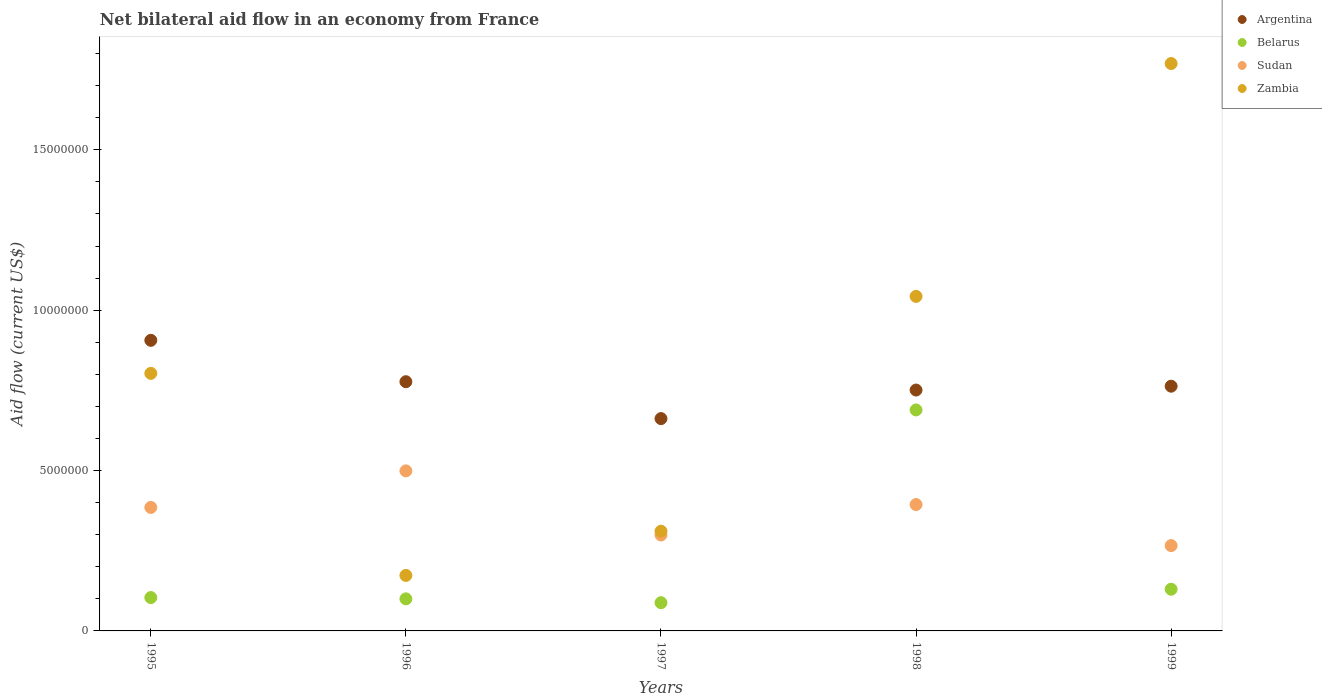What is the net bilateral aid flow in Argentina in 1997?
Keep it short and to the point. 6.62e+06. Across all years, what is the maximum net bilateral aid flow in Argentina?
Your answer should be very brief. 9.06e+06. Across all years, what is the minimum net bilateral aid flow in Belarus?
Give a very brief answer. 8.80e+05. In which year was the net bilateral aid flow in Sudan maximum?
Make the answer very short. 1996. What is the total net bilateral aid flow in Argentina in the graph?
Your answer should be compact. 3.86e+07. What is the difference between the net bilateral aid flow in Belarus in 1995 and that in 1998?
Provide a succinct answer. -5.85e+06. What is the difference between the net bilateral aid flow in Belarus in 1995 and the net bilateral aid flow in Zambia in 1996?
Your answer should be very brief. -6.90e+05. What is the average net bilateral aid flow in Sudan per year?
Offer a terse response. 3.69e+06. In the year 1996, what is the difference between the net bilateral aid flow in Zambia and net bilateral aid flow in Argentina?
Your answer should be compact. -6.04e+06. What is the ratio of the net bilateral aid flow in Sudan in 1997 to that in 1999?
Offer a terse response. 1.12. What is the difference between the highest and the second highest net bilateral aid flow in Sudan?
Provide a succinct answer. 1.05e+06. What is the difference between the highest and the lowest net bilateral aid flow in Belarus?
Your answer should be compact. 6.01e+06. Is the sum of the net bilateral aid flow in Zambia in 1995 and 1999 greater than the maximum net bilateral aid flow in Argentina across all years?
Provide a short and direct response. Yes. Does the net bilateral aid flow in Zambia monotonically increase over the years?
Your response must be concise. No. Is the net bilateral aid flow in Sudan strictly greater than the net bilateral aid flow in Argentina over the years?
Your answer should be very brief. No. Is the net bilateral aid flow in Belarus strictly less than the net bilateral aid flow in Sudan over the years?
Make the answer very short. No. How many dotlines are there?
Your answer should be compact. 4. Are the values on the major ticks of Y-axis written in scientific E-notation?
Provide a succinct answer. No. Does the graph contain any zero values?
Make the answer very short. No. Where does the legend appear in the graph?
Offer a very short reply. Top right. How are the legend labels stacked?
Offer a very short reply. Vertical. What is the title of the graph?
Provide a short and direct response. Net bilateral aid flow in an economy from France. Does "Turkmenistan" appear as one of the legend labels in the graph?
Offer a very short reply. No. What is the Aid flow (current US$) of Argentina in 1995?
Keep it short and to the point. 9.06e+06. What is the Aid flow (current US$) of Belarus in 1995?
Offer a very short reply. 1.04e+06. What is the Aid flow (current US$) in Sudan in 1995?
Your answer should be compact. 3.85e+06. What is the Aid flow (current US$) in Zambia in 1995?
Provide a succinct answer. 8.03e+06. What is the Aid flow (current US$) in Argentina in 1996?
Give a very brief answer. 7.77e+06. What is the Aid flow (current US$) of Sudan in 1996?
Offer a very short reply. 4.99e+06. What is the Aid flow (current US$) of Zambia in 1996?
Ensure brevity in your answer.  1.73e+06. What is the Aid flow (current US$) in Argentina in 1997?
Give a very brief answer. 6.62e+06. What is the Aid flow (current US$) in Belarus in 1997?
Provide a short and direct response. 8.80e+05. What is the Aid flow (current US$) of Sudan in 1997?
Your response must be concise. 2.99e+06. What is the Aid flow (current US$) of Zambia in 1997?
Keep it short and to the point. 3.11e+06. What is the Aid flow (current US$) of Argentina in 1998?
Ensure brevity in your answer.  7.51e+06. What is the Aid flow (current US$) of Belarus in 1998?
Provide a succinct answer. 6.89e+06. What is the Aid flow (current US$) of Sudan in 1998?
Give a very brief answer. 3.94e+06. What is the Aid flow (current US$) of Zambia in 1998?
Your response must be concise. 1.04e+07. What is the Aid flow (current US$) of Argentina in 1999?
Your response must be concise. 7.63e+06. What is the Aid flow (current US$) of Belarus in 1999?
Make the answer very short. 1.30e+06. What is the Aid flow (current US$) in Sudan in 1999?
Give a very brief answer. 2.66e+06. What is the Aid flow (current US$) in Zambia in 1999?
Give a very brief answer. 1.77e+07. Across all years, what is the maximum Aid flow (current US$) of Argentina?
Your answer should be compact. 9.06e+06. Across all years, what is the maximum Aid flow (current US$) in Belarus?
Provide a succinct answer. 6.89e+06. Across all years, what is the maximum Aid flow (current US$) of Sudan?
Give a very brief answer. 4.99e+06. Across all years, what is the maximum Aid flow (current US$) in Zambia?
Make the answer very short. 1.77e+07. Across all years, what is the minimum Aid flow (current US$) of Argentina?
Offer a terse response. 6.62e+06. Across all years, what is the minimum Aid flow (current US$) in Belarus?
Your response must be concise. 8.80e+05. Across all years, what is the minimum Aid flow (current US$) of Sudan?
Provide a short and direct response. 2.66e+06. Across all years, what is the minimum Aid flow (current US$) of Zambia?
Make the answer very short. 1.73e+06. What is the total Aid flow (current US$) in Argentina in the graph?
Ensure brevity in your answer.  3.86e+07. What is the total Aid flow (current US$) of Belarus in the graph?
Keep it short and to the point. 1.11e+07. What is the total Aid flow (current US$) of Sudan in the graph?
Give a very brief answer. 1.84e+07. What is the total Aid flow (current US$) in Zambia in the graph?
Keep it short and to the point. 4.10e+07. What is the difference between the Aid flow (current US$) of Argentina in 1995 and that in 1996?
Your answer should be compact. 1.29e+06. What is the difference between the Aid flow (current US$) of Sudan in 1995 and that in 1996?
Provide a short and direct response. -1.14e+06. What is the difference between the Aid flow (current US$) in Zambia in 1995 and that in 1996?
Your answer should be compact. 6.30e+06. What is the difference between the Aid flow (current US$) of Argentina in 1995 and that in 1997?
Your answer should be compact. 2.44e+06. What is the difference between the Aid flow (current US$) in Belarus in 1995 and that in 1997?
Ensure brevity in your answer.  1.60e+05. What is the difference between the Aid flow (current US$) in Sudan in 1995 and that in 1997?
Provide a succinct answer. 8.60e+05. What is the difference between the Aid flow (current US$) of Zambia in 1995 and that in 1997?
Your response must be concise. 4.92e+06. What is the difference between the Aid flow (current US$) of Argentina in 1995 and that in 1998?
Provide a succinct answer. 1.55e+06. What is the difference between the Aid flow (current US$) in Belarus in 1995 and that in 1998?
Keep it short and to the point. -5.85e+06. What is the difference between the Aid flow (current US$) in Sudan in 1995 and that in 1998?
Make the answer very short. -9.00e+04. What is the difference between the Aid flow (current US$) of Zambia in 1995 and that in 1998?
Ensure brevity in your answer.  -2.40e+06. What is the difference between the Aid flow (current US$) in Argentina in 1995 and that in 1999?
Your answer should be compact. 1.43e+06. What is the difference between the Aid flow (current US$) in Belarus in 1995 and that in 1999?
Make the answer very short. -2.60e+05. What is the difference between the Aid flow (current US$) of Sudan in 1995 and that in 1999?
Make the answer very short. 1.19e+06. What is the difference between the Aid flow (current US$) in Zambia in 1995 and that in 1999?
Your answer should be compact. -9.66e+06. What is the difference between the Aid flow (current US$) of Argentina in 1996 and that in 1997?
Keep it short and to the point. 1.15e+06. What is the difference between the Aid flow (current US$) of Belarus in 1996 and that in 1997?
Ensure brevity in your answer.  1.20e+05. What is the difference between the Aid flow (current US$) in Sudan in 1996 and that in 1997?
Ensure brevity in your answer.  2.00e+06. What is the difference between the Aid flow (current US$) of Zambia in 1996 and that in 1997?
Make the answer very short. -1.38e+06. What is the difference between the Aid flow (current US$) in Argentina in 1996 and that in 1998?
Keep it short and to the point. 2.60e+05. What is the difference between the Aid flow (current US$) of Belarus in 1996 and that in 1998?
Provide a succinct answer. -5.89e+06. What is the difference between the Aid flow (current US$) in Sudan in 1996 and that in 1998?
Make the answer very short. 1.05e+06. What is the difference between the Aid flow (current US$) of Zambia in 1996 and that in 1998?
Make the answer very short. -8.70e+06. What is the difference between the Aid flow (current US$) of Belarus in 1996 and that in 1999?
Provide a short and direct response. -3.00e+05. What is the difference between the Aid flow (current US$) of Sudan in 1996 and that in 1999?
Your answer should be very brief. 2.33e+06. What is the difference between the Aid flow (current US$) of Zambia in 1996 and that in 1999?
Make the answer very short. -1.60e+07. What is the difference between the Aid flow (current US$) of Argentina in 1997 and that in 1998?
Offer a terse response. -8.90e+05. What is the difference between the Aid flow (current US$) of Belarus in 1997 and that in 1998?
Provide a short and direct response. -6.01e+06. What is the difference between the Aid flow (current US$) of Sudan in 1997 and that in 1998?
Your answer should be compact. -9.50e+05. What is the difference between the Aid flow (current US$) in Zambia in 1997 and that in 1998?
Your response must be concise. -7.32e+06. What is the difference between the Aid flow (current US$) of Argentina in 1997 and that in 1999?
Keep it short and to the point. -1.01e+06. What is the difference between the Aid flow (current US$) of Belarus in 1997 and that in 1999?
Make the answer very short. -4.20e+05. What is the difference between the Aid flow (current US$) of Zambia in 1997 and that in 1999?
Keep it short and to the point. -1.46e+07. What is the difference between the Aid flow (current US$) of Belarus in 1998 and that in 1999?
Make the answer very short. 5.59e+06. What is the difference between the Aid flow (current US$) of Sudan in 1998 and that in 1999?
Ensure brevity in your answer.  1.28e+06. What is the difference between the Aid flow (current US$) of Zambia in 1998 and that in 1999?
Provide a short and direct response. -7.26e+06. What is the difference between the Aid flow (current US$) in Argentina in 1995 and the Aid flow (current US$) in Belarus in 1996?
Offer a terse response. 8.06e+06. What is the difference between the Aid flow (current US$) of Argentina in 1995 and the Aid flow (current US$) of Sudan in 1996?
Your response must be concise. 4.07e+06. What is the difference between the Aid flow (current US$) of Argentina in 1995 and the Aid flow (current US$) of Zambia in 1996?
Your response must be concise. 7.33e+06. What is the difference between the Aid flow (current US$) in Belarus in 1995 and the Aid flow (current US$) in Sudan in 1996?
Give a very brief answer. -3.95e+06. What is the difference between the Aid flow (current US$) in Belarus in 1995 and the Aid flow (current US$) in Zambia in 1996?
Your response must be concise. -6.90e+05. What is the difference between the Aid flow (current US$) of Sudan in 1995 and the Aid flow (current US$) of Zambia in 1996?
Offer a very short reply. 2.12e+06. What is the difference between the Aid flow (current US$) of Argentina in 1995 and the Aid flow (current US$) of Belarus in 1997?
Your answer should be very brief. 8.18e+06. What is the difference between the Aid flow (current US$) of Argentina in 1995 and the Aid flow (current US$) of Sudan in 1997?
Your answer should be compact. 6.07e+06. What is the difference between the Aid flow (current US$) in Argentina in 1995 and the Aid flow (current US$) in Zambia in 1997?
Give a very brief answer. 5.95e+06. What is the difference between the Aid flow (current US$) of Belarus in 1995 and the Aid flow (current US$) of Sudan in 1997?
Your response must be concise. -1.95e+06. What is the difference between the Aid flow (current US$) of Belarus in 1995 and the Aid flow (current US$) of Zambia in 1997?
Ensure brevity in your answer.  -2.07e+06. What is the difference between the Aid flow (current US$) in Sudan in 1995 and the Aid flow (current US$) in Zambia in 1997?
Offer a terse response. 7.40e+05. What is the difference between the Aid flow (current US$) in Argentina in 1995 and the Aid flow (current US$) in Belarus in 1998?
Give a very brief answer. 2.17e+06. What is the difference between the Aid flow (current US$) of Argentina in 1995 and the Aid flow (current US$) of Sudan in 1998?
Your answer should be very brief. 5.12e+06. What is the difference between the Aid flow (current US$) of Argentina in 1995 and the Aid flow (current US$) of Zambia in 1998?
Provide a succinct answer. -1.37e+06. What is the difference between the Aid flow (current US$) in Belarus in 1995 and the Aid flow (current US$) in Sudan in 1998?
Your answer should be very brief. -2.90e+06. What is the difference between the Aid flow (current US$) of Belarus in 1995 and the Aid flow (current US$) of Zambia in 1998?
Give a very brief answer. -9.39e+06. What is the difference between the Aid flow (current US$) in Sudan in 1995 and the Aid flow (current US$) in Zambia in 1998?
Give a very brief answer. -6.58e+06. What is the difference between the Aid flow (current US$) in Argentina in 1995 and the Aid flow (current US$) in Belarus in 1999?
Offer a very short reply. 7.76e+06. What is the difference between the Aid flow (current US$) in Argentina in 1995 and the Aid flow (current US$) in Sudan in 1999?
Keep it short and to the point. 6.40e+06. What is the difference between the Aid flow (current US$) of Argentina in 1995 and the Aid flow (current US$) of Zambia in 1999?
Give a very brief answer. -8.63e+06. What is the difference between the Aid flow (current US$) in Belarus in 1995 and the Aid flow (current US$) in Sudan in 1999?
Provide a succinct answer. -1.62e+06. What is the difference between the Aid flow (current US$) in Belarus in 1995 and the Aid flow (current US$) in Zambia in 1999?
Provide a succinct answer. -1.66e+07. What is the difference between the Aid flow (current US$) in Sudan in 1995 and the Aid flow (current US$) in Zambia in 1999?
Provide a succinct answer. -1.38e+07. What is the difference between the Aid flow (current US$) in Argentina in 1996 and the Aid flow (current US$) in Belarus in 1997?
Make the answer very short. 6.89e+06. What is the difference between the Aid flow (current US$) in Argentina in 1996 and the Aid flow (current US$) in Sudan in 1997?
Your answer should be very brief. 4.78e+06. What is the difference between the Aid flow (current US$) of Argentina in 1996 and the Aid flow (current US$) of Zambia in 1997?
Your answer should be very brief. 4.66e+06. What is the difference between the Aid flow (current US$) in Belarus in 1996 and the Aid flow (current US$) in Sudan in 1997?
Keep it short and to the point. -1.99e+06. What is the difference between the Aid flow (current US$) in Belarus in 1996 and the Aid flow (current US$) in Zambia in 1997?
Keep it short and to the point. -2.11e+06. What is the difference between the Aid flow (current US$) in Sudan in 1996 and the Aid flow (current US$) in Zambia in 1997?
Keep it short and to the point. 1.88e+06. What is the difference between the Aid flow (current US$) in Argentina in 1996 and the Aid flow (current US$) in Belarus in 1998?
Your answer should be very brief. 8.80e+05. What is the difference between the Aid flow (current US$) of Argentina in 1996 and the Aid flow (current US$) of Sudan in 1998?
Give a very brief answer. 3.83e+06. What is the difference between the Aid flow (current US$) of Argentina in 1996 and the Aid flow (current US$) of Zambia in 1998?
Keep it short and to the point. -2.66e+06. What is the difference between the Aid flow (current US$) in Belarus in 1996 and the Aid flow (current US$) in Sudan in 1998?
Provide a short and direct response. -2.94e+06. What is the difference between the Aid flow (current US$) in Belarus in 1996 and the Aid flow (current US$) in Zambia in 1998?
Your answer should be very brief. -9.43e+06. What is the difference between the Aid flow (current US$) of Sudan in 1996 and the Aid flow (current US$) of Zambia in 1998?
Provide a succinct answer. -5.44e+06. What is the difference between the Aid flow (current US$) in Argentina in 1996 and the Aid flow (current US$) in Belarus in 1999?
Offer a very short reply. 6.47e+06. What is the difference between the Aid flow (current US$) of Argentina in 1996 and the Aid flow (current US$) of Sudan in 1999?
Give a very brief answer. 5.11e+06. What is the difference between the Aid flow (current US$) in Argentina in 1996 and the Aid flow (current US$) in Zambia in 1999?
Offer a terse response. -9.92e+06. What is the difference between the Aid flow (current US$) in Belarus in 1996 and the Aid flow (current US$) in Sudan in 1999?
Ensure brevity in your answer.  -1.66e+06. What is the difference between the Aid flow (current US$) in Belarus in 1996 and the Aid flow (current US$) in Zambia in 1999?
Make the answer very short. -1.67e+07. What is the difference between the Aid flow (current US$) in Sudan in 1996 and the Aid flow (current US$) in Zambia in 1999?
Your answer should be compact. -1.27e+07. What is the difference between the Aid flow (current US$) in Argentina in 1997 and the Aid flow (current US$) in Sudan in 1998?
Your response must be concise. 2.68e+06. What is the difference between the Aid flow (current US$) in Argentina in 1997 and the Aid flow (current US$) in Zambia in 1998?
Your answer should be very brief. -3.81e+06. What is the difference between the Aid flow (current US$) of Belarus in 1997 and the Aid flow (current US$) of Sudan in 1998?
Provide a short and direct response. -3.06e+06. What is the difference between the Aid flow (current US$) of Belarus in 1997 and the Aid flow (current US$) of Zambia in 1998?
Provide a short and direct response. -9.55e+06. What is the difference between the Aid flow (current US$) in Sudan in 1997 and the Aid flow (current US$) in Zambia in 1998?
Make the answer very short. -7.44e+06. What is the difference between the Aid flow (current US$) in Argentina in 1997 and the Aid flow (current US$) in Belarus in 1999?
Your answer should be compact. 5.32e+06. What is the difference between the Aid flow (current US$) of Argentina in 1997 and the Aid flow (current US$) of Sudan in 1999?
Provide a short and direct response. 3.96e+06. What is the difference between the Aid flow (current US$) in Argentina in 1997 and the Aid flow (current US$) in Zambia in 1999?
Provide a succinct answer. -1.11e+07. What is the difference between the Aid flow (current US$) of Belarus in 1997 and the Aid flow (current US$) of Sudan in 1999?
Make the answer very short. -1.78e+06. What is the difference between the Aid flow (current US$) in Belarus in 1997 and the Aid flow (current US$) in Zambia in 1999?
Provide a succinct answer. -1.68e+07. What is the difference between the Aid flow (current US$) of Sudan in 1997 and the Aid flow (current US$) of Zambia in 1999?
Keep it short and to the point. -1.47e+07. What is the difference between the Aid flow (current US$) in Argentina in 1998 and the Aid flow (current US$) in Belarus in 1999?
Provide a short and direct response. 6.21e+06. What is the difference between the Aid flow (current US$) in Argentina in 1998 and the Aid flow (current US$) in Sudan in 1999?
Offer a terse response. 4.85e+06. What is the difference between the Aid flow (current US$) in Argentina in 1998 and the Aid flow (current US$) in Zambia in 1999?
Your answer should be compact. -1.02e+07. What is the difference between the Aid flow (current US$) in Belarus in 1998 and the Aid flow (current US$) in Sudan in 1999?
Give a very brief answer. 4.23e+06. What is the difference between the Aid flow (current US$) in Belarus in 1998 and the Aid flow (current US$) in Zambia in 1999?
Your answer should be very brief. -1.08e+07. What is the difference between the Aid flow (current US$) in Sudan in 1998 and the Aid flow (current US$) in Zambia in 1999?
Offer a terse response. -1.38e+07. What is the average Aid flow (current US$) in Argentina per year?
Give a very brief answer. 7.72e+06. What is the average Aid flow (current US$) in Belarus per year?
Provide a short and direct response. 2.22e+06. What is the average Aid flow (current US$) in Sudan per year?
Your answer should be very brief. 3.69e+06. What is the average Aid flow (current US$) in Zambia per year?
Your answer should be compact. 8.20e+06. In the year 1995, what is the difference between the Aid flow (current US$) in Argentina and Aid flow (current US$) in Belarus?
Offer a very short reply. 8.02e+06. In the year 1995, what is the difference between the Aid flow (current US$) of Argentina and Aid flow (current US$) of Sudan?
Make the answer very short. 5.21e+06. In the year 1995, what is the difference between the Aid flow (current US$) of Argentina and Aid flow (current US$) of Zambia?
Your answer should be compact. 1.03e+06. In the year 1995, what is the difference between the Aid flow (current US$) in Belarus and Aid flow (current US$) in Sudan?
Ensure brevity in your answer.  -2.81e+06. In the year 1995, what is the difference between the Aid flow (current US$) of Belarus and Aid flow (current US$) of Zambia?
Give a very brief answer. -6.99e+06. In the year 1995, what is the difference between the Aid flow (current US$) of Sudan and Aid flow (current US$) of Zambia?
Give a very brief answer. -4.18e+06. In the year 1996, what is the difference between the Aid flow (current US$) in Argentina and Aid flow (current US$) in Belarus?
Give a very brief answer. 6.77e+06. In the year 1996, what is the difference between the Aid flow (current US$) in Argentina and Aid flow (current US$) in Sudan?
Keep it short and to the point. 2.78e+06. In the year 1996, what is the difference between the Aid flow (current US$) of Argentina and Aid flow (current US$) of Zambia?
Offer a very short reply. 6.04e+06. In the year 1996, what is the difference between the Aid flow (current US$) of Belarus and Aid flow (current US$) of Sudan?
Your response must be concise. -3.99e+06. In the year 1996, what is the difference between the Aid flow (current US$) in Belarus and Aid flow (current US$) in Zambia?
Provide a succinct answer. -7.30e+05. In the year 1996, what is the difference between the Aid flow (current US$) of Sudan and Aid flow (current US$) of Zambia?
Make the answer very short. 3.26e+06. In the year 1997, what is the difference between the Aid flow (current US$) in Argentina and Aid flow (current US$) in Belarus?
Provide a succinct answer. 5.74e+06. In the year 1997, what is the difference between the Aid flow (current US$) of Argentina and Aid flow (current US$) of Sudan?
Offer a very short reply. 3.63e+06. In the year 1997, what is the difference between the Aid flow (current US$) in Argentina and Aid flow (current US$) in Zambia?
Your answer should be very brief. 3.51e+06. In the year 1997, what is the difference between the Aid flow (current US$) in Belarus and Aid flow (current US$) in Sudan?
Provide a short and direct response. -2.11e+06. In the year 1997, what is the difference between the Aid flow (current US$) in Belarus and Aid flow (current US$) in Zambia?
Make the answer very short. -2.23e+06. In the year 1997, what is the difference between the Aid flow (current US$) in Sudan and Aid flow (current US$) in Zambia?
Offer a very short reply. -1.20e+05. In the year 1998, what is the difference between the Aid flow (current US$) in Argentina and Aid flow (current US$) in Belarus?
Make the answer very short. 6.20e+05. In the year 1998, what is the difference between the Aid flow (current US$) in Argentina and Aid flow (current US$) in Sudan?
Your answer should be very brief. 3.57e+06. In the year 1998, what is the difference between the Aid flow (current US$) in Argentina and Aid flow (current US$) in Zambia?
Provide a succinct answer. -2.92e+06. In the year 1998, what is the difference between the Aid flow (current US$) in Belarus and Aid flow (current US$) in Sudan?
Your answer should be compact. 2.95e+06. In the year 1998, what is the difference between the Aid flow (current US$) in Belarus and Aid flow (current US$) in Zambia?
Give a very brief answer. -3.54e+06. In the year 1998, what is the difference between the Aid flow (current US$) of Sudan and Aid flow (current US$) of Zambia?
Provide a succinct answer. -6.49e+06. In the year 1999, what is the difference between the Aid flow (current US$) of Argentina and Aid flow (current US$) of Belarus?
Provide a short and direct response. 6.33e+06. In the year 1999, what is the difference between the Aid flow (current US$) in Argentina and Aid flow (current US$) in Sudan?
Your answer should be very brief. 4.97e+06. In the year 1999, what is the difference between the Aid flow (current US$) in Argentina and Aid flow (current US$) in Zambia?
Offer a very short reply. -1.01e+07. In the year 1999, what is the difference between the Aid flow (current US$) in Belarus and Aid flow (current US$) in Sudan?
Your answer should be very brief. -1.36e+06. In the year 1999, what is the difference between the Aid flow (current US$) of Belarus and Aid flow (current US$) of Zambia?
Your response must be concise. -1.64e+07. In the year 1999, what is the difference between the Aid flow (current US$) of Sudan and Aid flow (current US$) of Zambia?
Give a very brief answer. -1.50e+07. What is the ratio of the Aid flow (current US$) of Argentina in 1995 to that in 1996?
Make the answer very short. 1.17. What is the ratio of the Aid flow (current US$) of Sudan in 1995 to that in 1996?
Provide a succinct answer. 0.77. What is the ratio of the Aid flow (current US$) of Zambia in 1995 to that in 1996?
Your response must be concise. 4.64. What is the ratio of the Aid flow (current US$) of Argentina in 1995 to that in 1997?
Provide a succinct answer. 1.37. What is the ratio of the Aid flow (current US$) in Belarus in 1995 to that in 1997?
Provide a succinct answer. 1.18. What is the ratio of the Aid flow (current US$) in Sudan in 1995 to that in 1997?
Keep it short and to the point. 1.29. What is the ratio of the Aid flow (current US$) of Zambia in 1995 to that in 1997?
Your answer should be compact. 2.58. What is the ratio of the Aid flow (current US$) in Argentina in 1995 to that in 1998?
Offer a terse response. 1.21. What is the ratio of the Aid flow (current US$) in Belarus in 1995 to that in 1998?
Your response must be concise. 0.15. What is the ratio of the Aid flow (current US$) in Sudan in 1995 to that in 1998?
Provide a short and direct response. 0.98. What is the ratio of the Aid flow (current US$) of Zambia in 1995 to that in 1998?
Provide a succinct answer. 0.77. What is the ratio of the Aid flow (current US$) of Argentina in 1995 to that in 1999?
Offer a very short reply. 1.19. What is the ratio of the Aid flow (current US$) in Sudan in 1995 to that in 1999?
Provide a short and direct response. 1.45. What is the ratio of the Aid flow (current US$) in Zambia in 1995 to that in 1999?
Your response must be concise. 0.45. What is the ratio of the Aid flow (current US$) in Argentina in 1996 to that in 1997?
Your response must be concise. 1.17. What is the ratio of the Aid flow (current US$) of Belarus in 1996 to that in 1997?
Offer a very short reply. 1.14. What is the ratio of the Aid flow (current US$) of Sudan in 1996 to that in 1997?
Provide a succinct answer. 1.67. What is the ratio of the Aid flow (current US$) in Zambia in 1996 to that in 1997?
Your answer should be compact. 0.56. What is the ratio of the Aid flow (current US$) in Argentina in 1996 to that in 1998?
Ensure brevity in your answer.  1.03. What is the ratio of the Aid flow (current US$) of Belarus in 1996 to that in 1998?
Keep it short and to the point. 0.15. What is the ratio of the Aid flow (current US$) in Sudan in 1996 to that in 1998?
Your response must be concise. 1.27. What is the ratio of the Aid flow (current US$) in Zambia in 1996 to that in 1998?
Ensure brevity in your answer.  0.17. What is the ratio of the Aid flow (current US$) of Argentina in 1996 to that in 1999?
Give a very brief answer. 1.02. What is the ratio of the Aid flow (current US$) in Belarus in 1996 to that in 1999?
Your answer should be very brief. 0.77. What is the ratio of the Aid flow (current US$) of Sudan in 1996 to that in 1999?
Provide a short and direct response. 1.88. What is the ratio of the Aid flow (current US$) in Zambia in 1996 to that in 1999?
Make the answer very short. 0.1. What is the ratio of the Aid flow (current US$) in Argentina in 1997 to that in 1998?
Offer a very short reply. 0.88. What is the ratio of the Aid flow (current US$) of Belarus in 1997 to that in 1998?
Make the answer very short. 0.13. What is the ratio of the Aid flow (current US$) in Sudan in 1997 to that in 1998?
Offer a terse response. 0.76. What is the ratio of the Aid flow (current US$) in Zambia in 1997 to that in 1998?
Offer a very short reply. 0.3. What is the ratio of the Aid flow (current US$) in Argentina in 1997 to that in 1999?
Give a very brief answer. 0.87. What is the ratio of the Aid flow (current US$) in Belarus in 1997 to that in 1999?
Ensure brevity in your answer.  0.68. What is the ratio of the Aid flow (current US$) of Sudan in 1997 to that in 1999?
Ensure brevity in your answer.  1.12. What is the ratio of the Aid flow (current US$) of Zambia in 1997 to that in 1999?
Provide a succinct answer. 0.18. What is the ratio of the Aid flow (current US$) in Argentina in 1998 to that in 1999?
Your answer should be compact. 0.98. What is the ratio of the Aid flow (current US$) in Belarus in 1998 to that in 1999?
Your response must be concise. 5.3. What is the ratio of the Aid flow (current US$) in Sudan in 1998 to that in 1999?
Keep it short and to the point. 1.48. What is the ratio of the Aid flow (current US$) of Zambia in 1998 to that in 1999?
Make the answer very short. 0.59. What is the difference between the highest and the second highest Aid flow (current US$) in Argentina?
Provide a short and direct response. 1.29e+06. What is the difference between the highest and the second highest Aid flow (current US$) of Belarus?
Provide a succinct answer. 5.59e+06. What is the difference between the highest and the second highest Aid flow (current US$) in Sudan?
Ensure brevity in your answer.  1.05e+06. What is the difference between the highest and the second highest Aid flow (current US$) in Zambia?
Give a very brief answer. 7.26e+06. What is the difference between the highest and the lowest Aid flow (current US$) of Argentina?
Your answer should be very brief. 2.44e+06. What is the difference between the highest and the lowest Aid flow (current US$) in Belarus?
Your response must be concise. 6.01e+06. What is the difference between the highest and the lowest Aid flow (current US$) in Sudan?
Provide a succinct answer. 2.33e+06. What is the difference between the highest and the lowest Aid flow (current US$) in Zambia?
Your answer should be compact. 1.60e+07. 